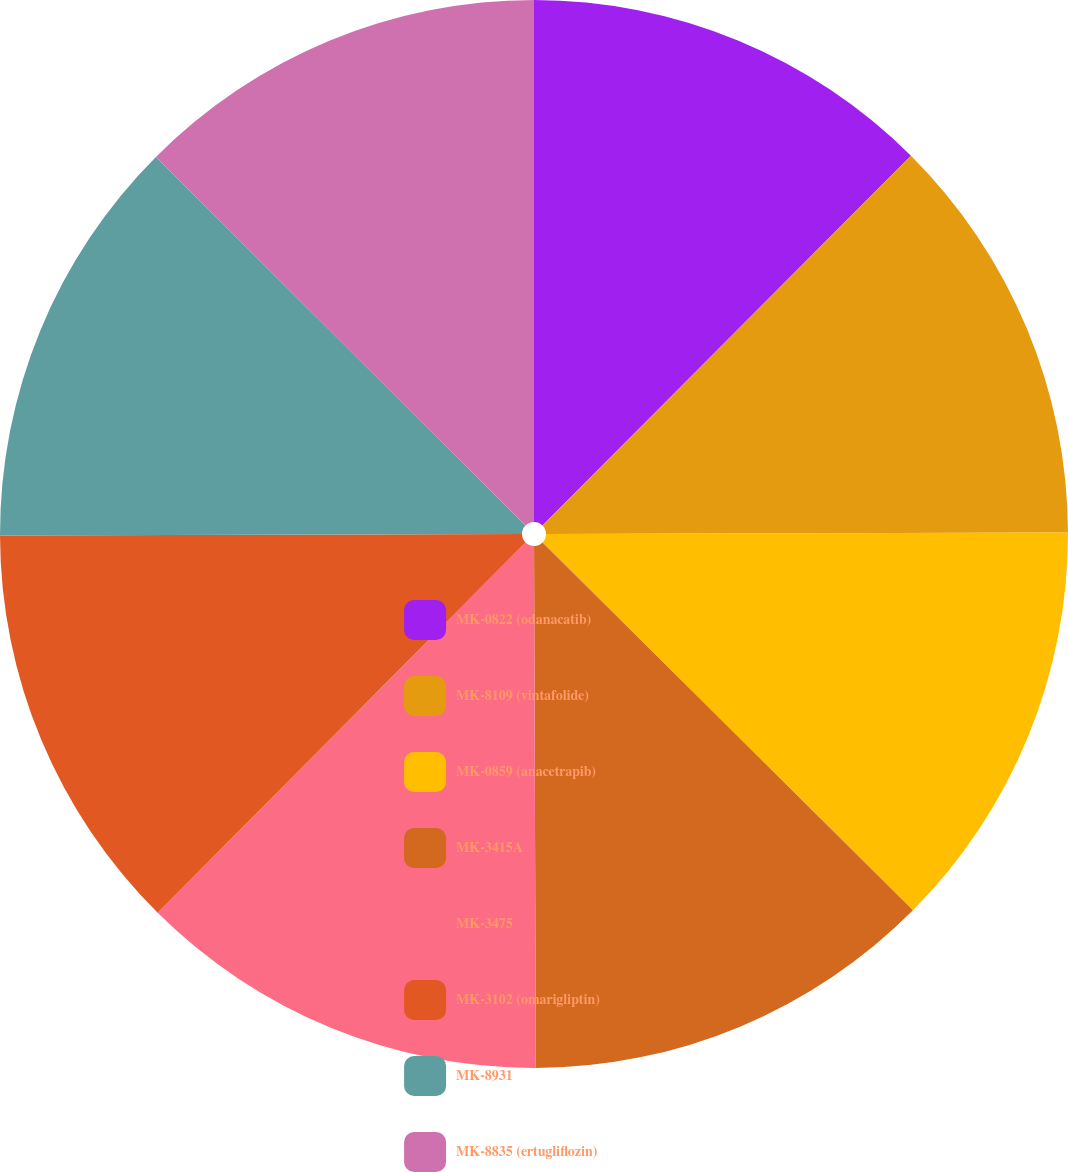Convert chart to OTSL. <chart><loc_0><loc_0><loc_500><loc_500><pie_chart><fcel>MK-0822 (odanacatib)<fcel>MK-8109 (vintafolide)<fcel>MK-0859 (anacetrapib)<fcel>MK-3415A<fcel>MK-3475<fcel>MK-3102 (omarigliptin)<fcel>MK-8931<fcel>MK-8835 (ertugliflozin)<nl><fcel>12.47%<fcel>12.48%<fcel>12.49%<fcel>12.5%<fcel>12.5%<fcel>12.51%<fcel>12.52%<fcel>12.52%<nl></chart> 